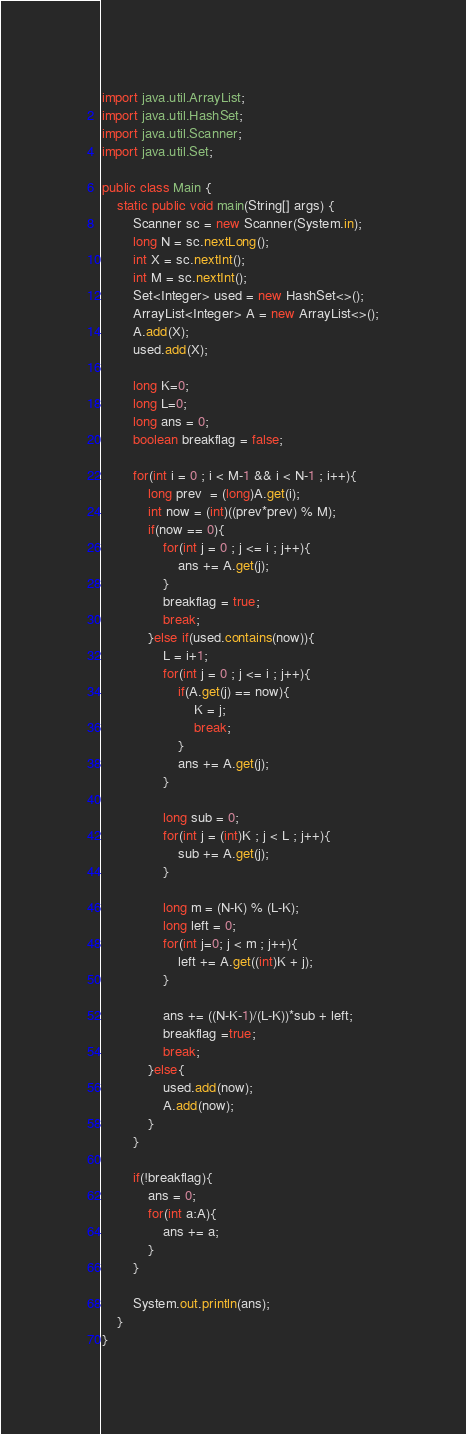<code> <loc_0><loc_0><loc_500><loc_500><_Java_>import java.util.ArrayList;
import java.util.HashSet;
import java.util.Scanner;
import java.util.Set;

public class Main {
    static public void main(String[] args) {
        Scanner sc = new Scanner(System.in);
        long N = sc.nextLong();
        int X = sc.nextInt();
        int M = sc.nextInt();
        Set<Integer> used = new HashSet<>();
        ArrayList<Integer> A = new ArrayList<>();
        A.add(X);
        used.add(X);

        long K=0;
        long L=0;
        long ans = 0;
        boolean breakflag = false;

        for(int i = 0 ; i < M-1 && i < N-1 ; i++){
            long prev  = (long)A.get(i);
            int now = (int)((prev*prev) % M);
            if(now == 0){
                for(int j = 0 ; j <= i ; j++){
                    ans += A.get(j);
                }
                breakflag = true;
                break;
            }else if(used.contains(now)){
                L = i+1;
                for(int j = 0 ; j <= i ; j++){
                    if(A.get(j) == now){
                        K = j;
                        break;
                    }
                    ans += A.get(j);
                }

                long sub = 0;
                for(int j = (int)K ; j < L ; j++){
                    sub += A.get(j);
                }

                long m = (N-K) % (L-K);
                long left = 0;
                for(int j=0; j < m ; j++){
                    left += A.get((int)K + j);
                }

                ans += ((N-K-1)/(L-K))*sub + left;
                breakflag =true;
                break;
            }else{
                used.add(now);
                A.add(now);
            }
        }

        if(!breakflag){
            ans = 0;
            for(int a:A){
                ans += a;
            }
        }

        System.out.println(ans);
    }
}
</code> 